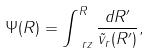<formula> <loc_0><loc_0><loc_500><loc_500>\Psi ( R ) = \int _ { \ r z } ^ { R } \frac { d R ^ { \prime } } { \tilde { v } _ { r } ( R ^ { \prime } ) } ,</formula> 